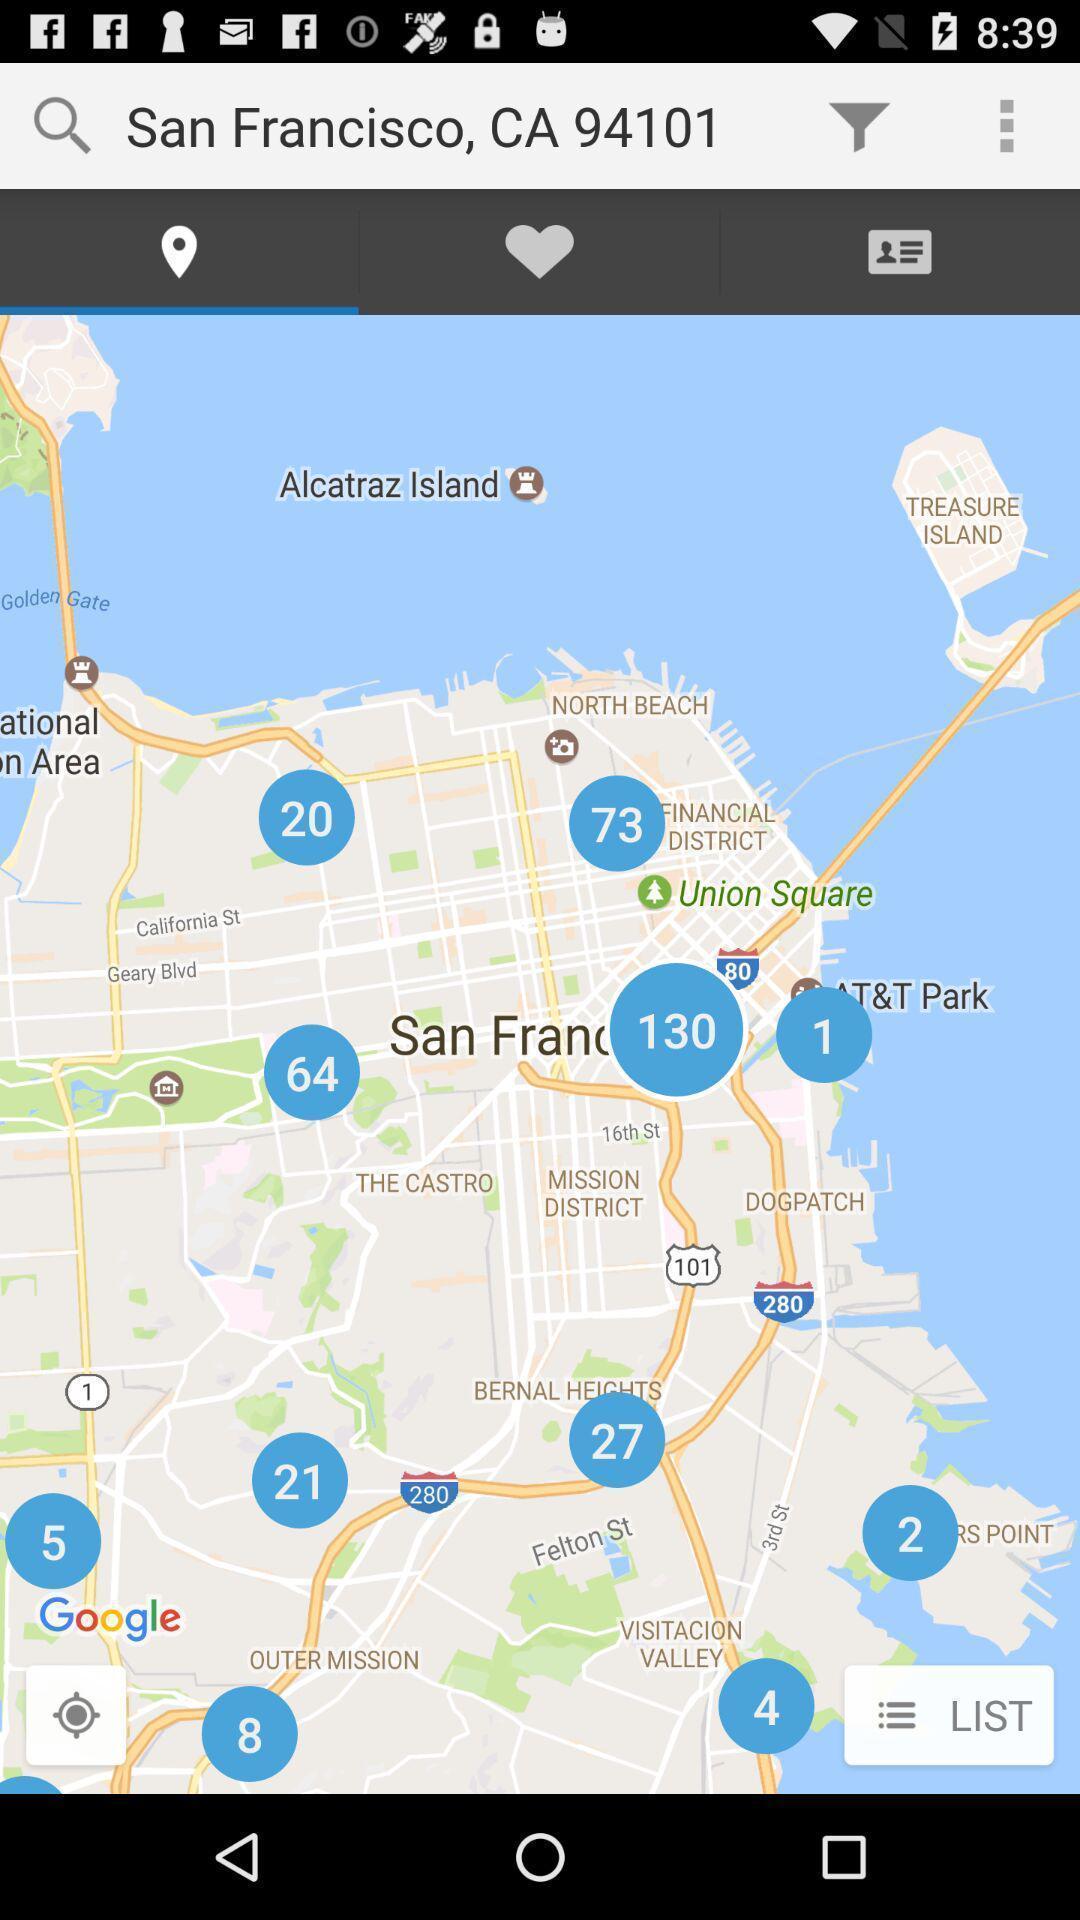Describe the key features of this screenshot. Screen displaying the map for location. 